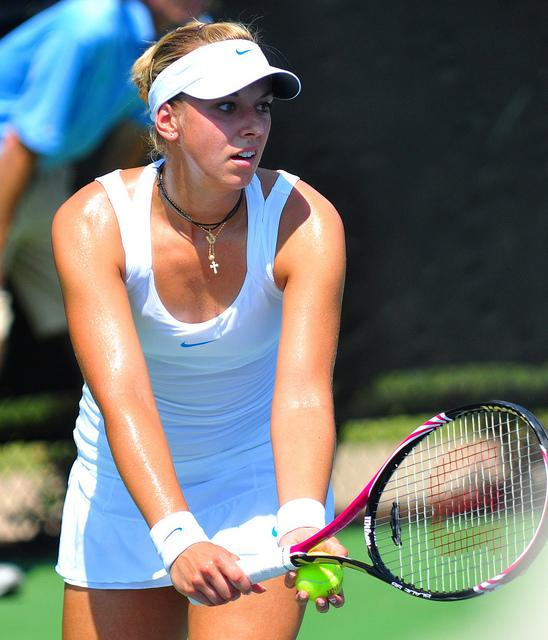When an athlete starts to overheat and sweat starts pouring there body is asking for what to replenish it?

Choices:
A) sunscreen
B) coffee
C) soda
D) water water 